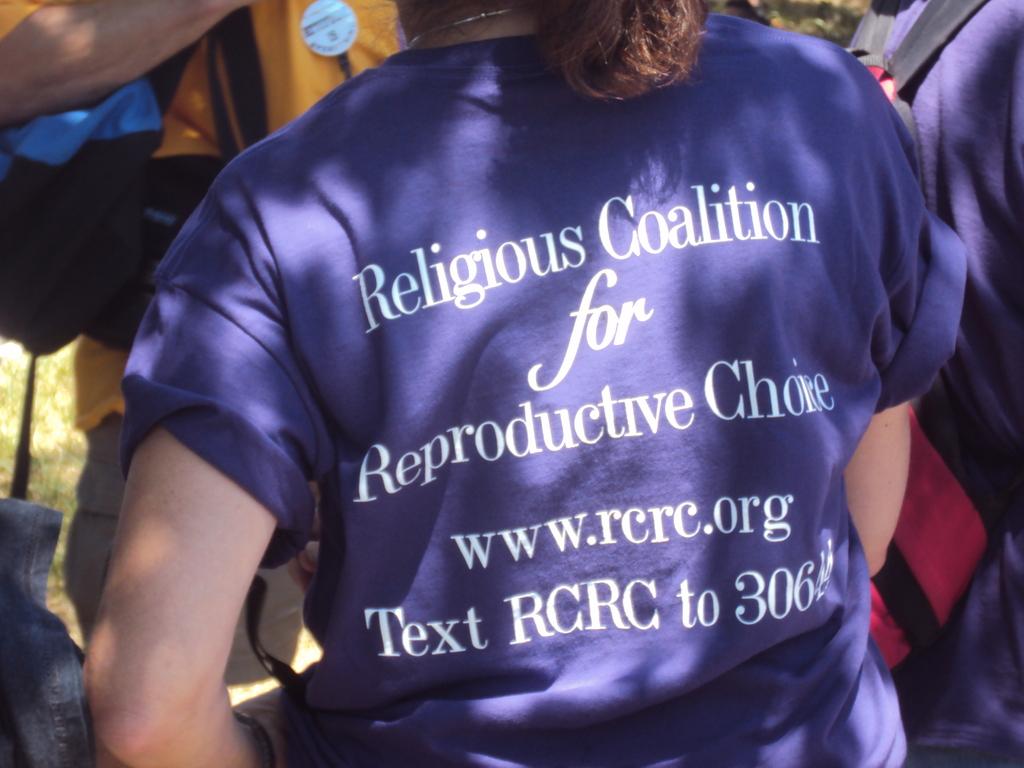What should you text?
Your response must be concise. Rcrc. What does the acronym rcrc stand for?
Provide a succinct answer. Religious coalition for reproductive choice. 